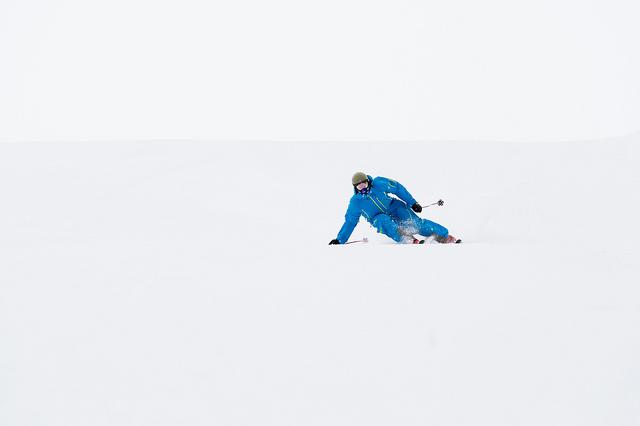Is the man injured?
Concise answer only. No. What direction is the skier leaning?
Quick response, please. Right. Is the man in the air?
Answer briefly. No. 